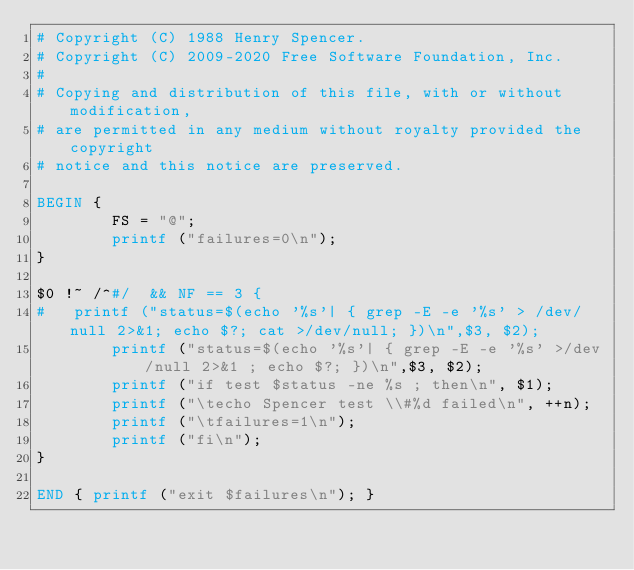Convert code to text. <code><loc_0><loc_0><loc_500><loc_500><_Awk_># Copyright (C) 1988 Henry Spencer.
# Copyright (C) 2009-2020 Free Software Foundation, Inc.
#
# Copying and distribution of this file, with or without modification,
# are permitted in any medium without royalty provided the copyright
# notice and this notice are preserved.

BEGIN {
        FS = "@";
        printf ("failures=0\n");
}

$0 !~ /^#/  && NF == 3 {
#	printf ("status=$(echo '%s'| { grep -E -e '%s' > /dev/null 2>&1; echo $?; cat >/dev/null; })\n",$3, $2);
        printf ("status=$(echo '%s'| { grep -E -e '%s' >/dev/null 2>&1 ; echo $?; })\n",$3, $2);
        printf ("if test $status -ne %s ; then\n", $1);
        printf ("\techo Spencer test \\#%d failed\n", ++n);
        printf ("\tfailures=1\n");
        printf ("fi\n");
}

END { printf ("exit $failures\n"); }
</code> 